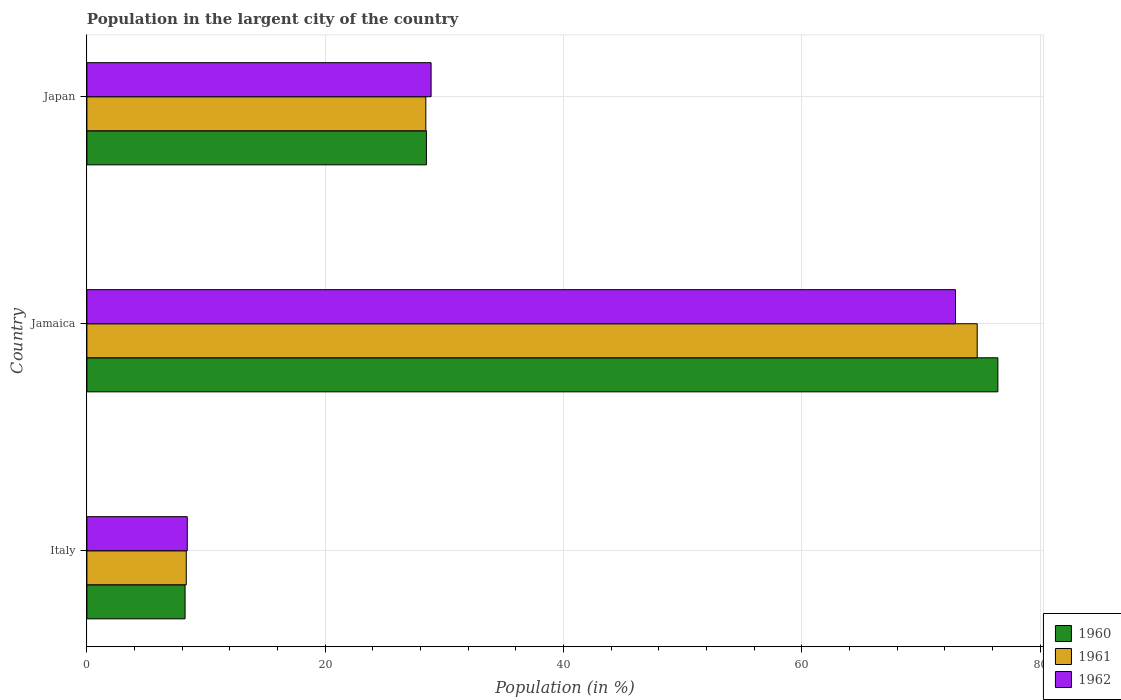Are the number of bars per tick equal to the number of legend labels?
Offer a terse response. Yes. What is the label of the 2nd group of bars from the top?
Give a very brief answer. Jamaica. What is the percentage of population in the largent city in 1961 in Jamaica?
Provide a succinct answer. 74.73. Across all countries, what is the maximum percentage of population in the largent city in 1962?
Ensure brevity in your answer.  72.91. Across all countries, what is the minimum percentage of population in the largent city in 1960?
Provide a short and direct response. 8.24. In which country was the percentage of population in the largent city in 1962 maximum?
Your response must be concise. Jamaica. What is the total percentage of population in the largent city in 1962 in the graph?
Provide a short and direct response. 110.22. What is the difference between the percentage of population in the largent city in 1961 in Jamaica and that in Japan?
Ensure brevity in your answer.  46.28. What is the difference between the percentage of population in the largent city in 1962 in Italy and the percentage of population in the largent city in 1960 in Japan?
Offer a very short reply. -20.07. What is the average percentage of population in the largent city in 1961 per country?
Provide a succinct answer. 37.17. What is the difference between the percentage of population in the largent city in 1960 and percentage of population in the largent city in 1961 in Jamaica?
Make the answer very short. 1.73. In how many countries, is the percentage of population in the largent city in 1962 greater than 60 %?
Your answer should be compact. 1. What is the ratio of the percentage of population in the largent city in 1961 in Italy to that in Jamaica?
Give a very brief answer. 0.11. Is the percentage of population in the largent city in 1960 in Italy less than that in Japan?
Ensure brevity in your answer.  Yes. What is the difference between the highest and the second highest percentage of population in the largent city in 1962?
Keep it short and to the point. 44.02. What is the difference between the highest and the lowest percentage of population in the largent city in 1961?
Provide a succinct answer. 66.39. In how many countries, is the percentage of population in the largent city in 1962 greater than the average percentage of population in the largent city in 1962 taken over all countries?
Keep it short and to the point. 1. What does the 1st bar from the top in Japan represents?
Provide a succinct answer. 1962. Is it the case that in every country, the sum of the percentage of population in the largent city in 1960 and percentage of population in the largent city in 1962 is greater than the percentage of population in the largent city in 1961?
Give a very brief answer. Yes. How many bars are there?
Your answer should be compact. 9. Are all the bars in the graph horizontal?
Your response must be concise. Yes. How many countries are there in the graph?
Your answer should be very brief. 3. Does the graph contain any zero values?
Your answer should be compact. No. Does the graph contain grids?
Offer a very short reply. Yes. How many legend labels are there?
Your answer should be compact. 3. What is the title of the graph?
Offer a terse response. Population in the largent city of the country. What is the Population (in %) in 1960 in Italy?
Offer a terse response. 8.24. What is the Population (in %) in 1961 in Italy?
Ensure brevity in your answer.  8.34. What is the Population (in %) in 1962 in Italy?
Ensure brevity in your answer.  8.42. What is the Population (in %) of 1960 in Jamaica?
Make the answer very short. 76.46. What is the Population (in %) of 1961 in Jamaica?
Provide a succinct answer. 74.73. What is the Population (in %) in 1962 in Jamaica?
Offer a very short reply. 72.91. What is the Population (in %) in 1960 in Japan?
Your answer should be very brief. 28.5. What is the Population (in %) of 1961 in Japan?
Provide a succinct answer. 28.45. What is the Population (in %) in 1962 in Japan?
Offer a very short reply. 28.89. Across all countries, what is the maximum Population (in %) of 1960?
Make the answer very short. 76.46. Across all countries, what is the maximum Population (in %) of 1961?
Your answer should be compact. 74.73. Across all countries, what is the maximum Population (in %) of 1962?
Your answer should be very brief. 72.91. Across all countries, what is the minimum Population (in %) of 1960?
Give a very brief answer. 8.24. Across all countries, what is the minimum Population (in %) of 1961?
Offer a terse response. 8.34. Across all countries, what is the minimum Population (in %) in 1962?
Provide a short and direct response. 8.42. What is the total Population (in %) of 1960 in the graph?
Your answer should be compact. 113.2. What is the total Population (in %) in 1961 in the graph?
Provide a succinct answer. 111.52. What is the total Population (in %) in 1962 in the graph?
Give a very brief answer. 110.22. What is the difference between the Population (in %) in 1960 in Italy and that in Jamaica?
Keep it short and to the point. -68.22. What is the difference between the Population (in %) of 1961 in Italy and that in Jamaica?
Give a very brief answer. -66.39. What is the difference between the Population (in %) of 1962 in Italy and that in Jamaica?
Offer a very short reply. -64.48. What is the difference between the Population (in %) of 1960 in Italy and that in Japan?
Provide a succinct answer. -20.26. What is the difference between the Population (in %) in 1961 in Italy and that in Japan?
Keep it short and to the point. -20.11. What is the difference between the Population (in %) of 1962 in Italy and that in Japan?
Keep it short and to the point. -20.47. What is the difference between the Population (in %) in 1960 in Jamaica and that in Japan?
Give a very brief answer. 47.97. What is the difference between the Population (in %) of 1961 in Jamaica and that in Japan?
Your response must be concise. 46.28. What is the difference between the Population (in %) in 1962 in Jamaica and that in Japan?
Provide a succinct answer. 44.02. What is the difference between the Population (in %) in 1960 in Italy and the Population (in %) in 1961 in Jamaica?
Offer a terse response. -66.49. What is the difference between the Population (in %) of 1960 in Italy and the Population (in %) of 1962 in Jamaica?
Make the answer very short. -64.67. What is the difference between the Population (in %) of 1961 in Italy and the Population (in %) of 1962 in Jamaica?
Give a very brief answer. -64.57. What is the difference between the Population (in %) of 1960 in Italy and the Population (in %) of 1961 in Japan?
Offer a very short reply. -20.21. What is the difference between the Population (in %) in 1960 in Italy and the Population (in %) in 1962 in Japan?
Offer a very short reply. -20.65. What is the difference between the Population (in %) of 1961 in Italy and the Population (in %) of 1962 in Japan?
Provide a short and direct response. -20.55. What is the difference between the Population (in %) in 1960 in Jamaica and the Population (in %) in 1961 in Japan?
Give a very brief answer. 48.02. What is the difference between the Population (in %) of 1960 in Jamaica and the Population (in %) of 1962 in Japan?
Offer a very short reply. 47.57. What is the difference between the Population (in %) of 1961 in Jamaica and the Population (in %) of 1962 in Japan?
Give a very brief answer. 45.84. What is the average Population (in %) in 1960 per country?
Provide a succinct answer. 37.73. What is the average Population (in %) in 1961 per country?
Your response must be concise. 37.17. What is the average Population (in %) of 1962 per country?
Keep it short and to the point. 36.74. What is the difference between the Population (in %) in 1960 and Population (in %) in 1961 in Italy?
Give a very brief answer. -0.1. What is the difference between the Population (in %) in 1960 and Population (in %) in 1962 in Italy?
Ensure brevity in your answer.  -0.18. What is the difference between the Population (in %) in 1961 and Population (in %) in 1962 in Italy?
Your answer should be compact. -0.08. What is the difference between the Population (in %) in 1960 and Population (in %) in 1961 in Jamaica?
Your answer should be compact. 1.74. What is the difference between the Population (in %) of 1960 and Population (in %) of 1962 in Jamaica?
Provide a short and direct response. 3.56. What is the difference between the Population (in %) of 1961 and Population (in %) of 1962 in Jamaica?
Your answer should be compact. 1.82. What is the difference between the Population (in %) of 1960 and Population (in %) of 1961 in Japan?
Keep it short and to the point. 0.05. What is the difference between the Population (in %) in 1960 and Population (in %) in 1962 in Japan?
Offer a terse response. -0.39. What is the difference between the Population (in %) of 1961 and Population (in %) of 1962 in Japan?
Offer a very short reply. -0.44. What is the ratio of the Population (in %) in 1960 in Italy to that in Jamaica?
Provide a succinct answer. 0.11. What is the ratio of the Population (in %) of 1961 in Italy to that in Jamaica?
Keep it short and to the point. 0.11. What is the ratio of the Population (in %) of 1962 in Italy to that in Jamaica?
Ensure brevity in your answer.  0.12. What is the ratio of the Population (in %) of 1960 in Italy to that in Japan?
Offer a very short reply. 0.29. What is the ratio of the Population (in %) in 1961 in Italy to that in Japan?
Your response must be concise. 0.29. What is the ratio of the Population (in %) in 1962 in Italy to that in Japan?
Provide a succinct answer. 0.29. What is the ratio of the Population (in %) of 1960 in Jamaica to that in Japan?
Provide a short and direct response. 2.68. What is the ratio of the Population (in %) in 1961 in Jamaica to that in Japan?
Your answer should be compact. 2.63. What is the ratio of the Population (in %) in 1962 in Jamaica to that in Japan?
Keep it short and to the point. 2.52. What is the difference between the highest and the second highest Population (in %) in 1960?
Provide a short and direct response. 47.97. What is the difference between the highest and the second highest Population (in %) of 1961?
Ensure brevity in your answer.  46.28. What is the difference between the highest and the second highest Population (in %) in 1962?
Make the answer very short. 44.02. What is the difference between the highest and the lowest Population (in %) of 1960?
Offer a very short reply. 68.22. What is the difference between the highest and the lowest Population (in %) in 1961?
Provide a short and direct response. 66.39. What is the difference between the highest and the lowest Population (in %) in 1962?
Your answer should be compact. 64.48. 